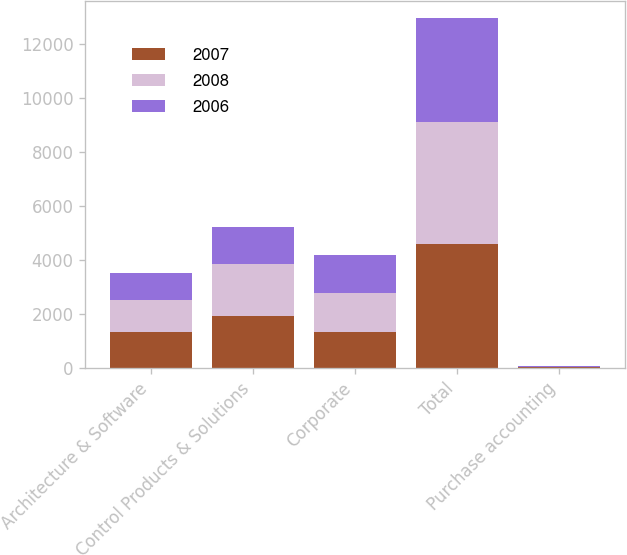Convert chart to OTSL. <chart><loc_0><loc_0><loc_500><loc_500><stacked_bar_chart><ecel><fcel>Architecture & Software<fcel>Control Products & Solutions<fcel>Corporate<fcel>Total<fcel>Purchase accounting<nl><fcel>2007<fcel>1337.3<fcel>1928.8<fcel>1326<fcel>4592.1<fcel>24.2<nl><fcel>2008<fcel>1163.6<fcel>1921.3<fcel>1460.9<fcel>4545.8<fcel>16.4<nl><fcel>2006<fcel>1030<fcel>1391.5<fcel>1410.3<fcel>3831.8<fcel>10.6<nl></chart> 